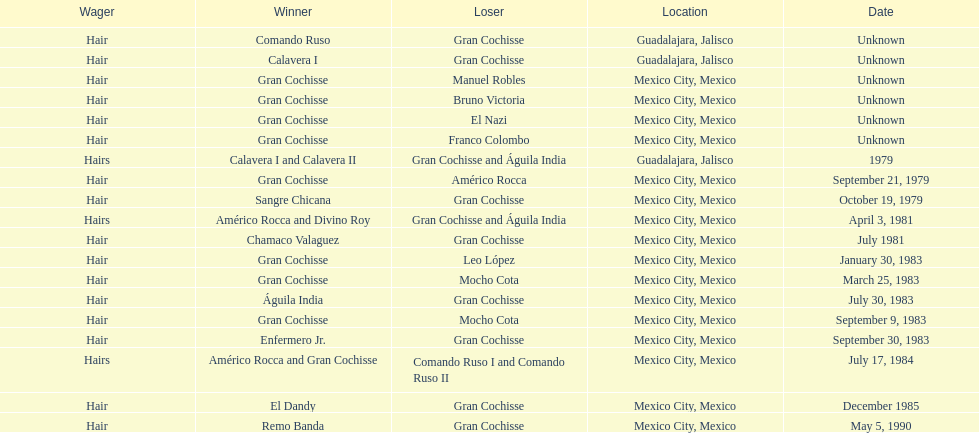How often has the bet been hair? 16. Could you help me parse every detail presented in this table? {'header': ['Wager', 'Winner', 'Loser', 'Location', 'Date'], 'rows': [['Hair', 'Comando Ruso', 'Gran Cochisse', 'Guadalajara, Jalisco', 'Unknown'], ['Hair', 'Calavera I', 'Gran Cochisse', 'Guadalajara, Jalisco', 'Unknown'], ['Hair', 'Gran Cochisse', 'Manuel Robles', 'Mexico City, Mexico', 'Unknown'], ['Hair', 'Gran Cochisse', 'Bruno Victoria', 'Mexico City, Mexico', 'Unknown'], ['Hair', 'Gran Cochisse', 'El Nazi', 'Mexico City, Mexico', 'Unknown'], ['Hair', 'Gran Cochisse', 'Franco Colombo', 'Mexico City, Mexico', 'Unknown'], ['Hairs', 'Calavera I and Calavera II', 'Gran Cochisse and Águila India', 'Guadalajara, Jalisco', '1979'], ['Hair', 'Gran Cochisse', 'Américo Rocca', 'Mexico City, Mexico', 'September 21, 1979'], ['Hair', 'Sangre Chicana', 'Gran Cochisse', 'Mexico City, Mexico', 'October 19, 1979'], ['Hairs', 'Américo Rocca and Divino Roy', 'Gran Cochisse and Águila India', 'Mexico City, Mexico', 'April 3, 1981'], ['Hair', 'Chamaco Valaguez', 'Gran Cochisse', 'Mexico City, Mexico', 'July 1981'], ['Hair', 'Gran Cochisse', 'Leo López', 'Mexico City, Mexico', 'January 30, 1983'], ['Hair', 'Gran Cochisse', 'Mocho Cota', 'Mexico City, Mexico', 'March 25, 1983'], ['Hair', 'Águila India', 'Gran Cochisse', 'Mexico City, Mexico', 'July 30, 1983'], ['Hair', 'Gran Cochisse', 'Mocho Cota', 'Mexico City, Mexico', 'September 9, 1983'], ['Hair', 'Enfermero Jr.', 'Gran Cochisse', 'Mexico City, Mexico', 'September 30, 1983'], ['Hairs', 'Américo Rocca and Gran Cochisse', 'Comando Ruso I and Comando Ruso II', 'Mexico City, Mexico', 'July 17, 1984'], ['Hair', 'El Dandy', 'Gran Cochisse', 'Mexico City, Mexico', 'December 1985'], ['Hair', 'Remo Banda', 'Gran Cochisse', 'Mexico City, Mexico', 'May 5, 1990']]} 